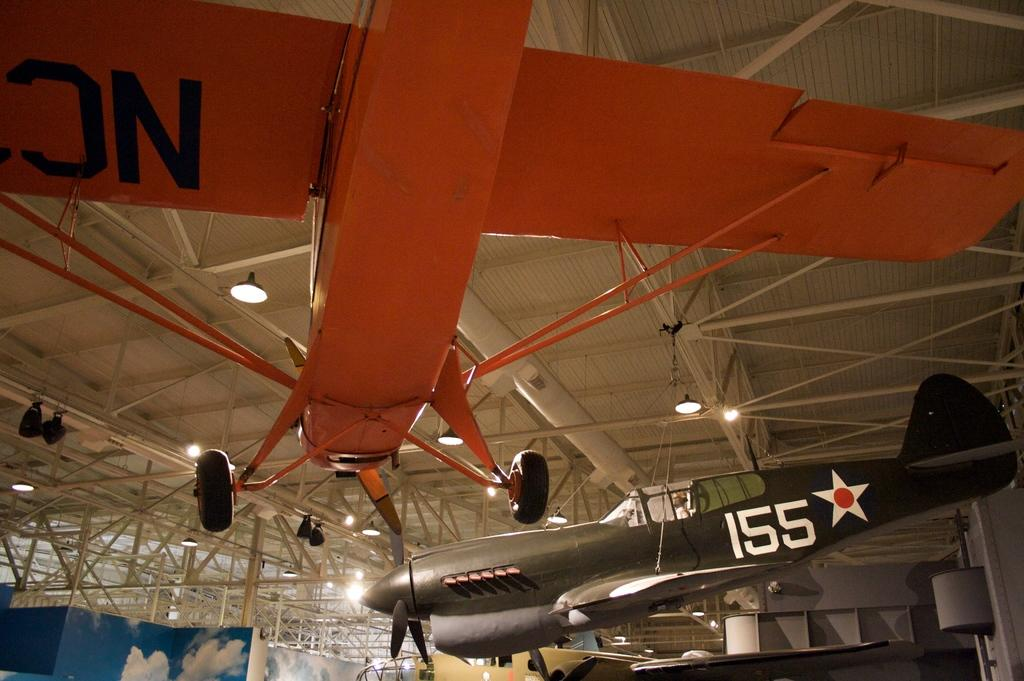<image>
Create a compact narrative representing the image presented. A plane with the number 155 is hung from the ceiling. 